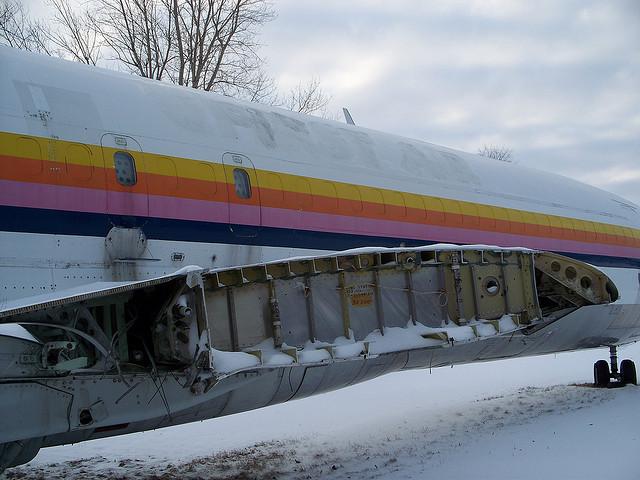How many different colors are on this plane?
Be succinct. 5. What happened to the wing?
Quick response, please. Broke. Is it cloudy?
Keep it brief. Yes. 